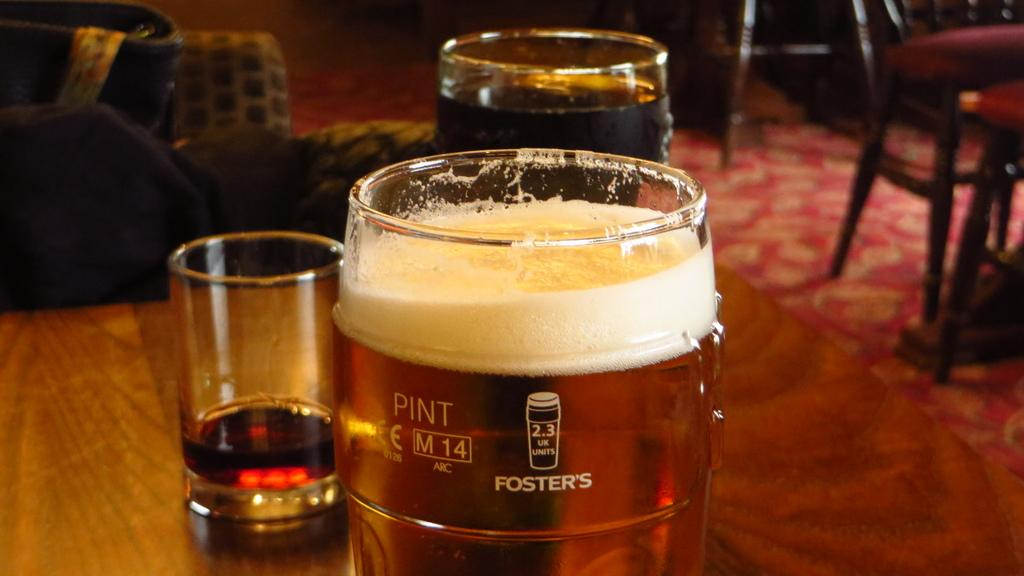<image>
Present a compact description of the photo's key features. A pint glass of Foster's sits on a wood table. 